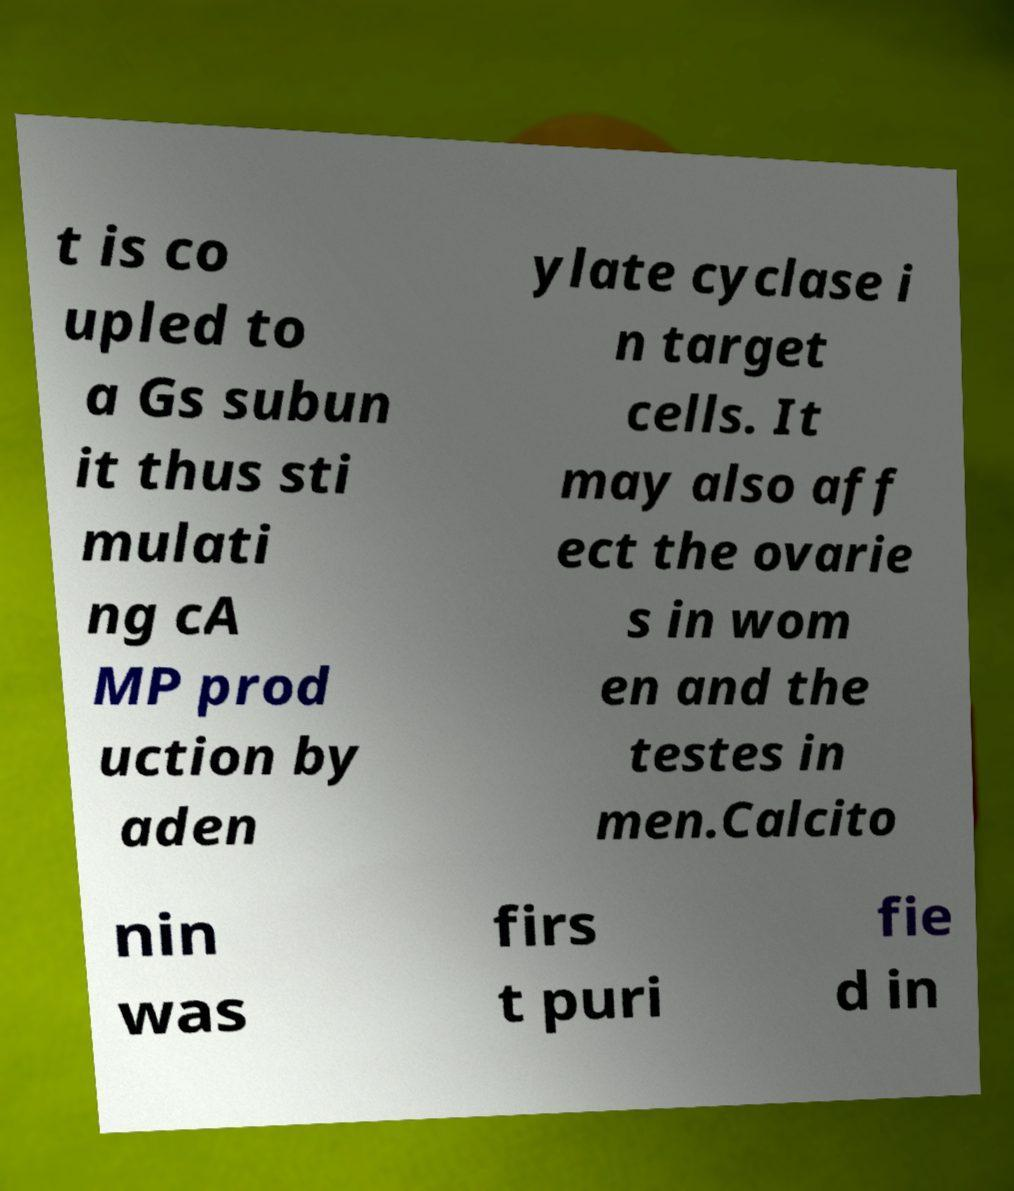Please identify and transcribe the text found in this image. t is co upled to a Gs subun it thus sti mulati ng cA MP prod uction by aden ylate cyclase i n target cells. It may also aff ect the ovarie s in wom en and the testes in men.Calcito nin was firs t puri fie d in 